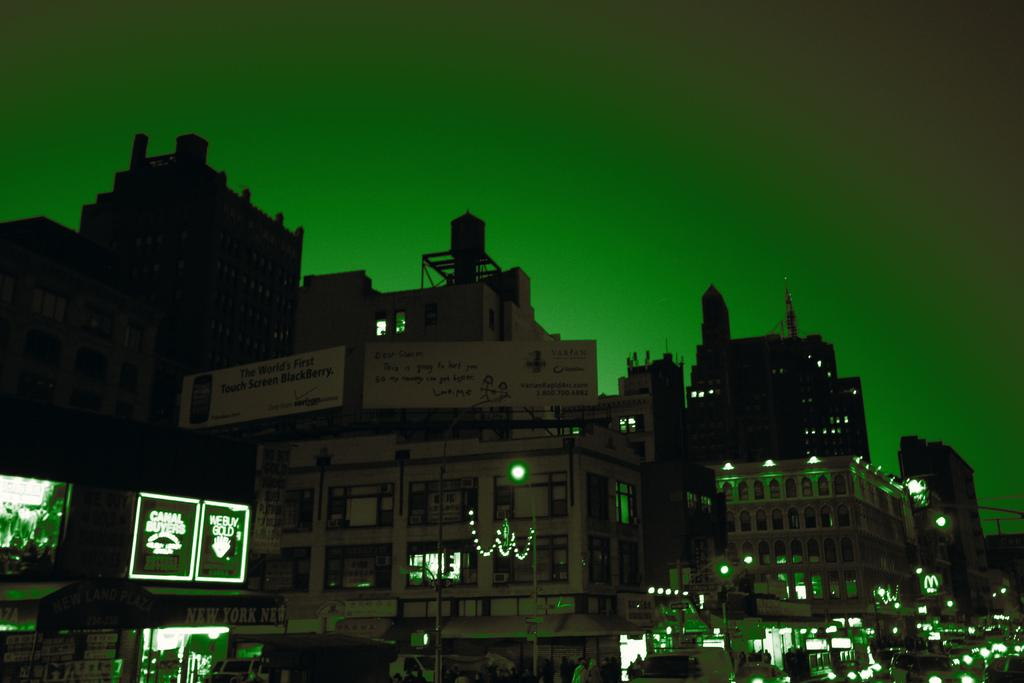What is the main subject in the center of the image? There are buildings in the center of the image. What type of ray can be seen flying over the buildings in the image? There is no ray present in the image; it only features buildings in the center. 